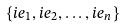<formula> <loc_0><loc_0><loc_500><loc_500>\{ i e _ { 1 } , i e _ { 2 } , \dots , i e _ { n } \}</formula> 